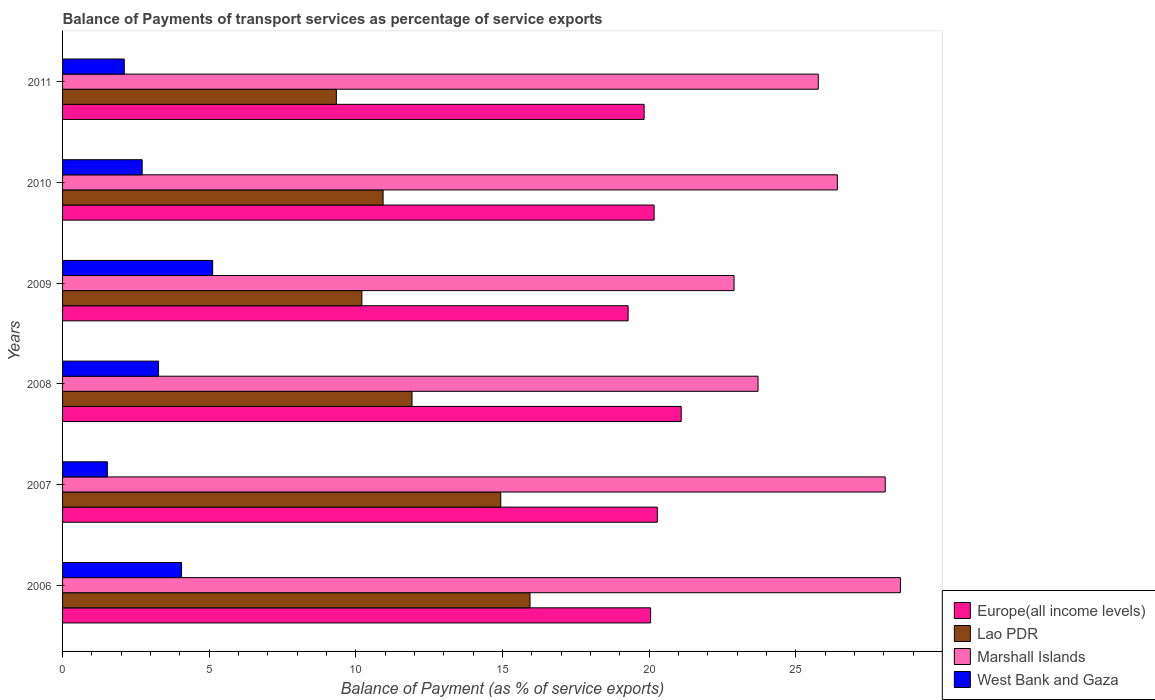How many bars are there on the 3rd tick from the top?
Provide a short and direct response. 4. What is the label of the 6th group of bars from the top?
Ensure brevity in your answer.  2006. What is the balance of payments of transport services in West Bank and Gaza in 2009?
Make the answer very short. 5.12. Across all years, what is the maximum balance of payments of transport services in West Bank and Gaza?
Offer a very short reply. 5.12. Across all years, what is the minimum balance of payments of transport services in West Bank and Gaza?
Offer a very short reply. 1.53. In which year was the balance of payments of transport services in Marshall Islands maximum?
Give a very brief answer. 2006. In which year was the balance of payments of transport services in West Bank and Gaza minimum?
Your answer should be compact. 2007. What is the total balance of payments of transport services in West Bank and Gaza in the graph?
Make the answer very short. 18.79. What is the difference between the balance of payments of transport services in Lao PDR in 2006 and that in 2011?
Give a very brief answer. 6.6. What is the difference between the balance of payments of transport services in Lao PDR in 2008 and the balance of payments of transport services in Europe(all income levels) in 2007?
Your answer should be very brief. -8.36. What is the average balance of payments of transport services in Lao PDR per year?
Offer a terse response. 12.21. In the year 2006, what is the difference between the balance of payments of transport services in Europe(all income levels) and balance of payments of transport services in Marshall Islands?
Provide a short and direct response. -8.52. What is the ratio of the balance of payments of transport services in Lao PDR in 2009 to that in 2010?
Keep it short and to the point. 0.93. Is the difference between the balance of payments of transport services in Europe(all income levels) in 2006 and 2010 greater than the difference between the balance of payments of transport services in Marshall Islands in 2006 and 2010?
Give a very brief answer. No. What is the difference between the highest and the second highest balance of payments of transport services in West Bank and Gaza?
Ensure brevity in your answer.  1.06. What is the difference between the highest and the lowest balance of payments of transport services in West Bank and Gaza?
Keep it short and to the point. 3.59. Is the sum of the balance of payments of transport services in Lao PDR in 2007 and 2011 greater than the maximum balance of payments of transport services in Europe(all income levels) across all years?
Your answer should be very brief. Yes. What does the 2nd bar from the top in 2008 represents?
Your answer should be very brief. Marshall Islands. What does the 1st bar from the bottom in 2008 represents?
Offer a terse response. Europe(all income levels). Is it the case that in every year, the sum of the balance of payments of transport services in West Bank and Gaza and balance of payments of transport services in Marshall Islands is greater than the balance of payments of transport services in Europe(all income levels)?
Your answer should be compact. Yes. What is the difference between two consecutive major ticks on the X-axis?
Give a very brief answer. 5. Does the graph contain any zero values?
Offer a terse response. No. Does the graph contain grids?
Offer a very short reply. No. Where does the legend appear in the graph?
Make the answer very short. Bottom right. How many legend labels are there?
Offer a terse response. 4. What is the title of the graph?
Your answer should be very brief. Balance of Payments of transport services as percentage of service exports. Does "Venezuela" appear as one of the legend labels in the graph?
Your answer should be very brief. No. What is the label or title of the X-axis?
Offer a very short reply. Balance of Payment (as % of service exports). What is the label or title of the Y-axis?
Ensure brevity in your answer.  Years. What is the Balance of Payment (as % of service exports) in Europe(all income levels) in 2006?
Offer a terse response. 20.05. What is the Balance of Payment (as % of service exports) of Lao PDR in 2006?
Offer a very short reply. 15.94. What is the Balance of Payment (as % of service exports) of Marshall Islands in 2006?
Offer a terse response. 28.56. What is the Balance of Payment (as % of service exports) of West Bank and Gaza in 2006?
Your answer should be very brief. 4.06. What is the Balance of Payment (as % of service exports) in Europe(all income levels) in 2007?
Offer a terse response. 20.28. What is the Balance of Payment (as % of service exports) of Lao PDR in 2007?
Your answer should be very brief. 14.94. What is the Balance of Payment (as % of service exports) of Marshall Islands in 2007?
Make the answer very short. 28.05. What is the Balance of Payment (as % of service exports) in West Bank and Gaza in 2007?
Your answer should be compact. 1.53. What is the Balance of Payment (as % of service exports) in Europe(all income levels) in 2008?
Your response must be concise. 21.09. What is the Balance of Payment (as % of service exports) of Lao PDR in 2008?
Your answer should be very brief. 11.91. What is the Balance of Payment (as % of service exports) in Marshall Islands in 2008?
Offer a very short reply. 23.71. What is the Balance of Payment (as % of service exports) of West Bank and Gaza in 2008?
Provide a succinct answer. 3.27. What is the Balance of Payment (as % of service exports) in Europe(all income levels) in 2009?
Ensure brevity in your answer.  19.28. What is the Balance of Payment (as % of service exports) in Lao PDR in 2009?
Give a very brief answer. 10.2. What is the Balance of Payment (as % of service exports) of Marshall Islands in 2009?
Ensure brevity in your answer.  22.89. What is the Balance of Payment (as % of service exports) in West Bank and Gaza in 2009?
Keep it short and to the point. 5.12. What is the Balance of Payment (as % of service exports) in Europe(all income levels) in 2010?
Offer a very short reply. 20.17. What is the Balance of Payment (as % of service exports) of Lao PDR in 2010?
Ensure brevity in your answer.  10.93. What is the Balance of Payment (as % of service exports) in Marshall Islands in 2010?
Your answer should be very brief. 26.41. What is the Balance of Payment (as % of service exports) in West Bank and Gaza in 2010?
Your response must be concise. 2.71. What is the Balance of Payment (as % of service exports) of Europe(all income levels) in 2011?
Your response must be concise. 19.83. What is the Balance of Payment (as % of service exports) in Lao PDR in 2011?
Make the answer very short. 9.33. What is the Balance of Payment (as % of service exports) in Marshall Islands in 2011?
Ensure brevity in your answer.  25.76. What is the Balance of Payment (as % of service exports) in West Bank and Gaza in 2011?
Offer a terse response. 2.1. Across all years, what is the maximum Balance of Payment (as % of service exports) in Europe(all income levels)?
Give a very brief answer. 21.09. Across all years, what is the maximum Balance of Payment (as % of service exports) in Lao PDR?
Keep it short and to the point. 15.94. Across all years, what is the maximum Balance of Payment (as % of service exports) in Marshall Islands?
Offer a very short reply. 28.56. Across all years, what is the maximum Balance of Payment (as % of service exports) of West Bank and Gaza?
Make the answer very short. 5.12. Across all years, what is the minimum Balance of Payment (as % of service exports) of Europe(all income levels)?
Your response must be concise. 19.28. Across all years, what is the minimum Balance of Payment (as % of service exports) of Lao PDR?
Your answer should be compact. 9.33. Across all years, what is the minimum Balance of Payment (as % of service exports) of Marshall Islands?
Provide a succinct answer. 22.89. Across all years, what is the minimum Balance of Payment (as % of service exports) in West Bank and Gaza?
Provide a succinct answer. 1.53. What is the total Balance of Payment (as % of service exports) of Europe(all income levels) in the graph?
Give a very brief answer. 120.69. What is the total Balance of Payment (as % of service exports) of Lao PDR in the graph?
Offer a very short reply. 73.25. What is the total Balance of Payment (as % of service exports) in Marshall Islands in the graph?
Provide a short and direct response. 155.39. What is the total Balance of Payment (as % of service exports) in West Bank and Gaza in the graph?
Make the answer very short. 18.79. What is the difference between the Balance of Payment (as % of service exports) in Europe(all income levels) in 2006 and that in 2007?
Provide a succinct answer. -0.23. What is the difference between the Balance of Payment (as % of service exports) in Marshall Islands in 2006 and that in 2007?
Provide a succinct answer. 0.52. What is the difference between the Balance of Payment (as % of service exports) of West Bank and Gaza in 2006 and that in 2007?
Your answer should be compact. 2.53. What is the difference between the Balance of Payment (as % of service exports) of Europe(all income levels) in 2006 and that in 2008?
Your response must be concise. -1.04. What is the difference between the Balance of Payment (as % of service exports) of Lao PDR in 2006 and that in 2008?
Ensure brevity in your answer.  4.02. What is the difference between the Balance of Payment (as % of service exports) of Marshall Islands in 2006 and that in 2008?
Make the answer very short. 4.85. What is the difference between the Balance of Payment (as % of service exports) of West Bank and Gaza in 2006 and that in 2008?
Give a very brief answer. 0.78. What is the difference between the Balance of Payment (as % of service exports) in Europe(all income levels) in 2006 and that in 2009?
Your response must be concise. 0.77. What is the difference between the Balance of Payment (as % of service exports) of Lao PDR in 2006 and that in 2009?
Make the answer very short. 5.73. What is the difference between the Balance of Payment (as % of service exports) in Marshall Islands in 2006 and that in 2009?
Keep it short and to the point. 5.67. What is the difference between the Balance of Payment (as % of service exports) of West Bank and Gaza in 2006 and that in 2009?
Keep it short and to the point. -1.06. What is the difference between the Balance of Payment (as % of service exports) of Europe(all income levels) in 2006 and that in 2010?
Keep it short and to the point. -0.12. What is the difference between the Balance of Payment (as % of service exports) in Lao PDR in 2006 and that in 2010?
Offer a very short reply. 5.01. What is the difference between the Balance of Payment (as % of service exports) of Marshall Islands in 2006 and that in 2010?
Your answer should be very brief. 2.15. What is the difference between the Balance of Payment (as % of service exports) of West Bank and Gaza in 2006 and that in 2010?
Offer a terse response. 1.34. What is the difference between the Balance of Payment (as % of service exports) of Europe(all income levels) in 2006 and that in 2011?
Ensure brevity in your answer.  0.22. What is the difference between the Balance of Payment (as % of service exports) in Lao PDR in 2006 and that in 2011?
Make the answer very short. 6.6. What is the difference between the Balance of Payment (as % of service exports) in Marshall Islands in 2006 and that in 2011?
Offer a terse response. 2.8. What is the difference between the Balance of Payment (as % of service exports) in West Bank and Gaza in 2006 and that in 2011?
Keep it short and to the point. 1.95. What is the difference between the Balance of Payment (as % of service exports) in Europe(all income levels) in 2007 and that in 2008?
Your answer should be compact. -0.82. What is the difference between the Balance of Payment (as % of service exports) in Lao PDR in 2007 and that in 2008?
Your answer should be very brief. 3.02. What is the difference between the Balance of Payment (as % of service exports) of Marshall Islands in 2007 and that in 2008?
Your answer should be very brief. 4.34. What is the difference between the Balance of Payment (as % of service exports) in West Bank and Gaza in 2007 and that in 2008?
Offer a terse response. -1.75. What is the difference between the Balance of Payment (as % of service exports) of Europe(all income levels) in 2007 and that in 2009?
Your answer should be very brief. 0.99. What is the difference between the Balance of Payment (as % of service exports) of Lao PDR in 2007 and that in 2009?
Your answer should be compact. 4.73. What is the difference between the Balance of Payment (as % of service exports) of Marshall Islands in 2007 and that in 2009?
Keep it short and to the point. 5.15. What is the difference between the Balance of Payment (as % of service exports) in West Bank and Gaza in 2007 and that in 2009?
Offer a very short reply. -3.59. What is the difference between the Balance of Payment (as % of service exports) of Europe(all income levels) in 2007 and that in 2010?
Provide a short and direct response. 0.11. What is the difference between the Balance of Payment (as % of service exports) in Lao PDR in 2007 and that in 2010?
Make the answer very short. 4.01. What is the difference between the Balance of Payment (as % of service exports) of Marshall Islands in 2007 and that in 2010?
Your response must be concise. 1.63. What is the difference between the Balance of Payment (as % of service exports) of West Bank and Gaza in 2007 and that in 2010?
Ensure brevity in your answer.  -1.19. What is the difference between the Balance of Payment (as % of service exports) of Europe(all income levels) in 2007 and that in 2011?
Ensure brevity in your answer.  0.45. What is the difference between the Balance of Payment (as % of service exports) of Lao PDR in 2007 and that in 2011?
Provide a short and direct response. 5.6. What is the difference between the Balance of Payment (as % of service exports) in Marshall Islands in 2007 and that in 2011?
Your response must be concise. 2.28. What is the difference between the Balance of Payment (as % of service exports) in West Bank and Gaza in 2007 and that in 2011?
Offer a terse response. -0.58. What is the difference between the Balance of Payment (as % of service exports) of Europe(all income levels) in 2008 and that in 2009?
Ensure brevity in your answer.  1.81. What is the difference between the Balance of Payment (as % of service exports) in Lao PDR in 2008 and that in 2009?
Provide a short and direct response. 1.71. What is the difference between the Balance of Payment (as % of service exports) of Marshall Islands in 2008 and that in 2009?
Ensure brevity in your answer.  0.82. What is the difference between the Balance of Payment (as % of service exports) in West Bank and Gaza in 2008 and that in 2009?
Keep it short and to the point. -1.85. What is the difference between the Balance of Payment (as % of service exports) in Europe(all income levels) in 2008 and that in 2010?
Keep it short and to the point. 0.92. What is the difference between the Balance of Payment (as % of service exports) in Lao PDR in 2008 and that in 2010?
Make the answer very short. 0.99. What is the difference between the Balance of Payment (as % of service exports) in Marshall Islands in 2008 and that in 2010?
Offer a terse response. -2.7. What is the difference between the Balance of Payment (as % of service exports) in West Bank and Gaza in 2008 and that in 2010?
Provide a short and direct response. 0.56. What is the difference between the Balance of Payment (as % of service exports) in Europe(all income levels) in 2008 and that in 2011?
Provide a succinct answer. 1.26. What is the difference between the Balance of Payment (as % of service exports) of Lao PDR in 2008 and that in 2011?
Keep it short and to the point. 2.58. What is the difference between the Balance of Payment (as % of service exports) of Marshall Islands in 2008 and that in 2011?
Offer a very short reply. -2.05. What is the difference between the Balance of Payment (as % of service exports) of West Bank and Gaza in 2008 and that in 2011?
Offer a very short reply. 1.17. What is the difference between the Balance of Payment (as % of service exports) in Europe(all income levels) in 2009 and that in 2010?
Your answer should be very brief. -0.89. What is the difference between the Balance of Payment (as % of service exports) of Lao PDR in 2009 and that in 2010?
Keep it short and to the point. -0.72. What is the difference between the Balance of Payment (as % of service exports) in Marshall Islands in 2009 and that in 2010?
Make the answer very short. -3.52. What is the difference between the Balance of Payment (as % of service exports) of West Bank and Gaza in 2009 and that in 2010?
Offer a terse response. 2.4. What is the difference between the Balance of Payment (as % of service exports) in Europe(all income levels) in 2009 and that in 2011?
Provide a short and direct response. -0.55. What is the difference between the Balance of Payment (as % of service exports) in Lao PDR in 2009 and that in 2011?
Your response must be concise. 0.87. What is the difference between the Balance of Payment (as % of service exports) of Marshall Islands in 2009 and that in 2011?
Provide a short and direct response. -2.87. What is the difference between the Balance of Payment (as % of service exports) in West Bank and Gaza in 2009 and that in 2011?
Offer a very short reply. 3.01. What is the difference between the Balance of Payment (as % of service exports) in Europe(all income levels) in 2010 and that in 2011?
Make the answer very short. 0.34. What is the difference between the Balance of Payment (as % of service exports) in Lao PDR in 2010 and that in 2011?
Your answer should be very brief. 1.59. What is the difference between the Balance of Payment (as % of service exports) of Marshall Islands in 2010 and that in 2011?
Offer a terse response. 0.65. What is the difference between the Balance of Payment (as % of service exports) of West Bank and Gaza in 2010 and that in 2011?
Provide a short and direct response. 0.61. What is the difference between the Balance of Payment (as % of service exports) of Europe(all income levels) in 2006 and the Balance of Payment (as % of service exports) of Lao PDR in 2007?
Provide a succinct answer. 5.11. What is the difference between the Balance of Payment (as % of service exports) of Europe(all income levels) in 2006 and the Balance of Payment (as % of service exports) of Marshall Islands in 2007?
Provide a succinct answer. -8. What is the difference between the Balance of Payment (as % of service exports) in Europe(all income levels) in 2006 and the Balance of Payment (as % of service exports) in West Bank and Gaza in 2007?
Your answer should be very brief. 18.52. What is the difference between the Balance of Payment (as % of service exports) of Lao PDR in 2006 and the Balance of Payment (as % of service exports) of Marshall Islands in 2007?
Offer a terse response. -12.11. What is the difference between the Balance of Payment (as % of service exports) of Lao PDR in 2006 and the Balance of Payment (as % of service exports) of West Bank and Gaza in 2007?
Offer a very short reply. 14.41. What is the difference between the Balance of Payment (as % of service exports) in Marshall Islands in 2006 and the Balance of Payment (as % of service exports) in West Bank and Gaza in 2007?
Provide a succinct answer. 27.04. What is the difference between the Balance of Payment (as % of service exports) in Europe(all income levels) in 2006 and the Balance of Payment (as % of service exports) in Lao PDR in 2008?
Keep it short and to the point. 8.14. What is the difference between the Balance of Payment (as % of service exports) in Europe(all income levels) in 2006 and the Balance of Payment (as % of service exports) in Marshall Islands in 2008?
Offer a terse response. -3.66. What is the difference between the Balance of Payment (as % of service exports) in Europe(all income levels) in 2006 and the Balance of Payment (as % of service exports) in West Bank and Gaza in 2008?
Ensure brevity in your answer.  16.78. What is the difference between the Balance of Payment (as % of service exports) in Lao PDR in 2006 and the Balance of Payment (as % of service exports) in Marshall Islands in 2008?
Your answer should be very brief. -7.77. What is the difference between the Balance of Payment (as % of service exports) in Lao PDR in 2006 and the Balance of Payment (as % of service exports) in West Bank and Gaza in 2008?
Give a very brief answer. 12.66. What is the difference between the Balance of Payment (as % of service exports) in Marshall Islands in 2006 and the Balance of Payment (as % of service exports) in West Bank and Gaza in 2008?
Keep it short and to the point. 25.29. What is the difference between the Balance of Payment (as % of service exports) in Europe(all income levels) in 2006 and the Balance of Payment (as % of service exports) in Lao PDR in 2009?
Your answer should be compact. 9.84. What is the difference between the Balance of Payment (as % of service exports) in Europe(all income levels) in 2006 and the Balance of Payment (as % of service exports) in Marshall Islands in 2009?
Ensure brevity in your answer.  -2.84. What is the difference between the Balance of Payment (as % of service exports) of Europe(all income levels) in 2006 and the Balance of Payment (as % of service exports) of West Bank and Gaza in 2009?
Offer a terse response. 14.93. What is the difference between the Balance of Payment (as % of service exports) of Lao PDR in 2006 and the Balance of Payment (as % of service exports) of Marshall Islands in 2009?
Keep it short and to the point. -6.96. What is the difference between the Balance of Payment (as % of service exports) in Lao PDR in 2006 and the Balance of Payment (as % of service exports) in West Bank and Gaza in 2009?
Ensure brevity in your answer.  10.82. What is the difference between the Balance of Payment (as % of service exports) in Marshall Islands in 2006 and the Balance of Payment (as % of service exports) in West Bank and Gaza in 2009?
Your response must be concise. 23.45. What is the difference between the Balance of Payment (as % of service exports) in Europe(all income levels) in 2006 and the Balance of Payment (as % of service exports) in Lao PDR in 2010?
Your answer should be very brief. 9.12. What is the difference between the Balance of Payment (as % of service exports) of Europe(all income levels) in 2006 and the Balance of Payment (as % of service exports) of Marshall Islands in 2010?
Make the answer very short. -6.37. What is the difference between the Balance of Payment (as % of service exports) in Europe(all income levels) in 2006 and the Balance of Payment (as % of service exports) in West Bank and Gaza in 2010?
Make the answer very short. 17.33. What is the difference between the Balance of Payment (as % of service exports) of Lao PDR in 2006 and the Balance of Payment (as % of service exports) of Marshall Islands in 2010?
Offer a terse response. -10.48. What is the difference between the Balance of Payment (as % of service exports) in Lao PDR in 2006 and the Balance of Payment (as % of service exports) in West Bank and Gaza in 2010?
Provide a succinct answer. 13.22. What is the difference between the Balance of Payment (as % of service exports) of Marshall Islands in 2006 and the Balance of Payment (as % of service exports) of West Bank and Gaza in 2010?
Your response must be concise. 25.85. What is the difference between the Balance of Payment (as % of service exports) in Europe(all income levels) in 2006 and the Balance of Payment (as % of service exports) in Lao PDR in 2011?
Make the answer very short. 10.71. What is the difference between the Balance of Payment (as % of service exports) of Europe(all income levels) in 2006 and the Balance of Payment (as % of service exports) of Marshall Islands in 2011?
Offer a terse response. -5.72. What is the difference between the Balance of Payment (as % of service exports) in Europe(all income levels) in 2006 and the Balance of Payment (as % of service exports) in West Bank and Gaza in 2011?
Ensure brevity in your answer.  17.94. What is the difference between the Balance of Payment (as % of service exports) in Lao PDR in 2006 and the Balance of Payment (as % of service exports) in Marshall Islands in 2011?
Your response must be concise. -9.83. What is the difference between the Balance of Payment (as % of service exports) of Lao PDR in 2006 and the Balance of Payment (as % of service exports) of West Bank and Gaza in 2011?
Provide a succinct answer. 13.83. What is the difference between the Balance of Payment (as % of service exports) of Marshall Islands in 2006 and the Balance of Payment (as % of service exports) of West Bank and Gaza in 2011?
Provide a succinct answer. 26.46. What is the difference between the Balance of Payment (as % of service exports) of Europe(all income levels) in 2007 and the Balance of Payment (as % of service exports) of Lao PDR in 2008?
Your answer should be compact. 8.36. What is the difference between the Balance of Payment (as % of service exports) in Europe(all income levels) in 2007 and the Balance of Payment (as % of service exports) in Marshall Islands in 2008?
Keep it short and to the point. -3.43. What is the difference between the Balance of Payment (as % of service exports) in Europe(all income levels) in 2007 and the Balance of Payment (as % of service exports) in West Bank and Gaza in 2008?
Make the answer very short. 17. What is the difference between the Balance of Payment (as % of service exports) in Lao PDR in 2007 and the Balance of Payment (as % of service exports) in Marshall Islands in 2008?
Offer a very short reply. -8.77. What is the difference between the Balance of Payment (as % of service exports) in Lao PDR in 2007 and the Balance of Payment (as % of service exports) in West Bank and Gaza in 2008?
Make the answer very short. 11.67. What is the difference between the Balance of Payment (as % of service exports) in Marshall Islands in 2007 and the Balance of Payment (as % of service exports) in West Bank and Gaza in 2008?
Provide a succinct answer. 24.77. What is the difference between the Balance of Payment (as % of service exports) of Europe(all income levels) in 2007 and the Balance of Payment (as % of service exports) of Lao PDR in 2009?
Your response must be concise. 10.07. What is the difference between the Balance of Payment (as % of service exports) in Europe(all income levels) in 2007 and the Balance of Payment (as % of service exports) in Marshall Islands in 2009?
Your answer should be very brief. -2.62. What is the difference between the Balance of Payment (as % of service exports) of Europe(all income levels) in 2007 and the Balance of Payment (as % of service exports) of West Bank and Gaza in 2009?
Your answer should be compact. 15.16. What is the difference between the Balance of Payment (as % of service exports) in Lao PDR in 2007 and the Balance of Payment (as % of service exports) in Marshall Islands in 2009?
Your answer should be very brief. -7.95. What is the difference between the Balance of Payment (as % of service exports) in Lao PDR in 2007 and the Balance of Payment (as % of service exports) in West Bank and Gaza in 2009?
Provide a short and direct response. 9.82. What is the difference between the Balance of Payment (as % of service exports) of Marshall Islands in 2007 and the Balance of Payment (as % of service exports) of West Bank and Gaza in 2009?
Offer a terse response. 22.93. What is the difference between the Balance of Payment (as % of service exports) in Europe(all income levels) in 2007 and the Balance of Payment (as % of service exports) in Lao PDR in 2010?
Your answer should be very brief. 9.35. What is the difference between the Balance of Payment (as % of service exports) in Europe(all income levels) in 2007 and the Balance of Payment (as % of service exports) in Marshall Islands in 2010?
Your response must be concise. -6.14. What is the difference between the Balance of Payment (as % of service exports) in Europe(all income levels) in 2007 and the Balance of Payment (as % of service exports) in West Bank and Gaza in 2010?
Ensure brevity in your answer.  17.56. What is the difference between the Balance of Payment (as % of service exports) of Lao PDR in 2007 and the Balance of Payment (as % of service exports) of Marshall Islands in 2010?
Provide a short and direct response. -11.48. What is the difference between the Balance of Payment (as % of service exports) in Lao PDR in 2007 and the Balance of Payment (as % of service exports) in West Bank and Gaza in 2010?
Provide a succinct answer. 12.22. What is the difference between the Balance of Payment (as % of service exports) of Marshall Islands in 2007 and the Balance of Payment (as % of service exports) of West Bank and Gaza in 2010?
Your answer should be very brief. 25.33. What is the difference between the Balance of Payment (as % of service exports) in Europe(all income levels) in 2007 and the Balance of Payment (as % of service exports) in Lao PDR in 2011?
Offer a very short reply. 10.94. What is the difference between the Balance of Payment (as % of service exports) of Europe(all income levels) in 2007 and the Balance of Payment (as % of service exports) of Marshall Islands in 2011?
Your response must be concise. -5.49. What is the difference between the Balance of Payment (as % of service exports) of Europe(all income levels) in 2007 and the Balance of Payment (as % of service exports) of West Bank and Gaza in 2011?
Provide a short and direct response. 18.17. What is the difference between the Balance of Payment (as % of service exports) in Lao PDR in 2007 and the Balance of Payment (as % of service exports) in Marshall Islands in 2011?
Your response must be concise. -10.83. What is the difference between the Balance of Payment (as % of service exports) in Lao PDR in 2007 and the Balance of Payment (as % of service exports) in West Bank and Gaza in 2011?
Your response must be concise. 12.83. What is the difference between the Balance of Payment (as % of service exports) of Marshall Islands in 2007 and the Balance of Payment (as % of service exports) of West Bank and Gaza in 2011?
Make the answer very short. 25.94. What is the difference between the Balance of Payment (as % of service exports) of Europe(all income levels) in 2008 and the Balance of Payment (as % of service exports) of Lao PDR in 2009?
Offer a very short reply. 10.89. What is the difference between the Balance of Payment (as % of service exports) in Europe(all income levels) in 2008 and the Balance of Payment (as % of service exports) in Marshall Islands in 2009?
Ensure brevity in your answer.  -1.8. What is the difference between the Balance of Payment (as % of service exports) in Europe(all income levels) in 2008 and the Balance of Payment (as % of service exports) in West Bank and Gaza in 2009?
Offer a very short reply. 15.97. What is the difference between the Balance of Payment (as % of service exports) in Lao PDR in 2008 and the Balance of Payment (as % of service exports) in Marshall Islands in 2009?
Ensure brevity in your answer.  -10.98. What is the difference between the Balance of Payment (as % of service exports) in Lao PDR in 2008 and the Balance of Payment (as % of service exports) in West Bank and Gaza in 2009?
Keep it short and to the point. 6.8. What is the difference between the Balance of Payment (as % of service exports) in Marshall Islands in 2008 and the Balance of Payment (as % of service exports) in West Bank and Gaza in 2009?
Your answer should be compact. 18.59. What is the difference between the Balance of Payment (as % of service exports) in Europe(all income levels) in 2008 and the Balance of Payment (as % of service exports) in Lao PDR in 2010?
Keep it short and to the point. 10.16. What is the difference between the Balance of Payment (as % of service exports) of Europe(all income levels) in 2008 and the Balance of Payment (as % of service exports) of Marshall Islands in 2010?
Your answer should be compact. -5.32. What is the difference between the Balance of Payment (as % of service exports) of Europe(all income levels) in 2008 and the Balance of Payment (as % of service exports) of West Bank and Gaza in 2010?
Keep it short and to the point. 18.38. What is the difference between the Balance of Payment (as % of service exports) in Lao PDR in 2008 and the Balance of Payment (as % of service exports) in Marshall Islands in 2010?
Your answer should be compact. -14.5. What is the difference between the Balance of Payment (as % of service exports) of Lao PDR in 2008 and the Balance of Payment (as % of service exports) of West Bank and Gaza in 2010?
Your response must be concise. 9.2. What is the difference between the Balance of Payment (as % of service exports) in Marshall Islands in 2008 and the Balance of Payment (as % of service exports) in West Bank and Gaza in 2010?
Give a very brief answer. 21. What is the difference between the Balance of Payment (as % of service exports) of Europe(all income levels) in 2008 and the Balance of Payment (as % of service exports) of Lao PDR in 2011?
Offer a terse response. 11.76. What is the difference between the Balance of Payment (as % of service exports) of Europe(all income levels) in 2008 and the Balance of Payment (as % of service exports) of Marshall Islands in 2011?
Ensure brevity in your answer.  -4.67. What is the difference between the Balance of Payment (as % of service exports) of Europe(all income levels) in 2008 and the Balance of Payment (as % of service exports) of West Bank and Gaza in 2011?
Your answer should be compact. 18.99. What is the difference between the Balance of Payment (as % of service exports) in Lao PDR in 2008 and the Balance of Payment (as % of service exports) in Marshall Islands in 2011?
Provide a succinct answer. -13.85. What is the difference between the Balance of Payment (as % of service exports) of Lao PDR in 2008 and the Balance of Payment (as % of service exports) of West Bank and Gaza in 2011?
Provide a short and direct response. 9.81. What is the difference between the Balance of Payment (as % of service exports) in Marshall Islands in 2008 and the Balance of Payment (as % of service exports) in West Bank and Gaza in 2011?
Provide a short and direct response. 21.61. What is the difference between the Balance of Payment (as % of service exports) of Europe(all income levels) in 2009 and the Balance of Payment (as % of service exports) of Lao PDR in 2010?
Your answer should be compact. 8.35. What is the difference between the Balance of Payment (as % of service exports) of Europe(all income levels) in 2009 and the Balance of Payment (as % of service exports) of Marshall Islands in 2010?
Provide a succinct answer. -7.13. What is the difference between the Balance of Payment (as % of service exports) in Europe(all income levels) in 2009 and the Balance of Payment (as % of service exports) in West Bank and Gaza in 2010?
Offer a terse response. 16.57. What is the difference between the Balance of Payment (as % of service exports) of Lao PDR in 2009 and the Balance of Payment (as % of service exports) of Marshall Islands in 2010?
Provide a short and direct response. -16.21. What is the difference between the Balance of Payment (as % of service exports) in Lao PDR in 2009 and the Balance of Payment (as % of service exports) in West Bank and Gaza in 2010?
Your response must be concise. 7.49. What is the difference between the Balance of Payment (as % of service exports) of Marshall Islands in 2009 and the Balance of Payment (as % of service exports) of West Bank and Gaza in 2010?
Your answer should be very brief. 20.18. What is the difference between the Balance of Payment (as % of service exports) in Europe(all income levels) in 2009 and the Balance of Payment (as % of service exports) in Lao PDR in 2011?
Ensure brevity in your answer.  9.95. What is the difference between the Balance of Payment (as % of service exports) of Europe(all income levels) in 2009 and the Balance of Payment (as % of service exports) of Marshall Islands in 2011?
Ensure brevity in your answer.  -6.48. What is the difference between the Balance of Payment (as % of service exports) in Europe(all income levels) in 2009 and the Balance of Payment (as % of service exports) in West Bank and Gaza in 2011?
Ensure brevity in your answer.  17.18. What is the difference between the Balance of Payment (as % of service exports) of Lao PDR in 2009 and the Balance of Payment (as % of service exports) of Marshall Islands in 2011?
Make the answer very short. -15.56. What is the difference between the Balance of Payment (as % of service exports) of Lao PDR in 2009 and the Balance of Payment (as % of service exports) of West Bank and Gaza in 2011?
Offer a very short reply. 8.1. What is the difference between the Balance of Payment (as % of service exports) of Marshall Islands in 2009 and the Balance of Payment (as % of service exports) of West Bank and Gaza in 2011?
Make the answer very short. 20.79. What is the difference between the Balance of Payment (as % of service exports) of Europe(all income levels) in 2010 and the Balance of Payment (as % of service exports) of Lao PDR in 2011?
Provide a short and direct response. 10.83. What is the difference between the Balance of Payment (as % of service exports) in Europe(all income levels) in 2010 and the Balance of Payment (as % of service exports) in Marshall Islands in 2011?
Provide a short and direct response. -5.6. What is the difference between the Balance of Payment (as % of service exports) in Europe(all income levels) in 2010 and the Balance of Payment (as % of service exports) in West Bank and Gaza in 2011?
Ensure brevity in your answer.  18.06. What is the difference between the Balance of Payment (as % of service exports) in Lao PDR in 2010 and the Balance of Payment (as % of service exports) in Marshall Islands in 2011?
Provide a succinct answer. -14.84. What is the difference between the Balance of Payment (as % of service exports) of Lao PDR in 2010 and the Balance of Payment (as % of service exports) of West Bank and Gaza in 2011?
Ensure brevity in your answer.  8.82. What is the difference between the Balance of Payment (as % of service exports) in Marshall Islands in 2010 and the Balance of Payment (as % of service exports) in West Bank and Gaza in 2011?
Offer a terse response. 24.31. What is the average Balance of Payment (as % of service exports) in Europe(all income levels) per year?
Your answer should be very brief. 20.11. What is the average Balance of Payment (as % of service exports) in Lao PDR per year?
Provide a succinct answer. 12.21. What is the average Balance of Payment (as % of service exports) of Marshall Islands per year?
Provide a succinct answer. 25.9. What is the average Balance of Payment (as % of service exports) of West Bank and Gaza per year?
Provide a short and direct response. 3.13. In the year 2006, what is the difference between the Balance of Payment (as % of service exports) in Europe(all income levels) and Balance of Payment (as % of service exports) in Lao PDR?
Your answer should be very brief. 4.11. In the year 2006, what is the difference between the Balance of Payment (as % of service exports) of Europe(all income levels) and Balance of Payment (as % of service exports) of Marshall Islands?
Provide a short and direct response. -8.52. In the year 2006, what is the difference between the Balance of Payment (as % of service exports) in Europe(all income levels) and Balance of Payment (as % of service exports) in West Bank and Gaza?
Ensure brevity in your answer.  15.99. In the year 2006, what is the difference between the Balance of Payment (as % of service exports) of Lao PDR and Balance of Payment (as % of service exports) of Marshall Islands?
Provide a short and direct response. -12.63. In the year 2006, what is the difference between the Balance of Payment (as % of service exports) of Lao PDR and Balance of Payment (as % of service exports) of West Bank and Gaza?
Make the answer very short. 11.88. In the year 2006, what is the difference between the Balance of Payment (as % of service exports) of Marshall Islands and Balance of Payment (as % of service exports) of West Bank and Gaza?
Your answer should be very brief. 24.51. In the year 2007, what is the difference between the Balance of Payment (as % of service exports) of Europe(all income levels) and Balance of Payment (as % of service exports) of Lao PDR?
Ensure brevity in your answer.  5.34. In the year 2007, what is the difference between the Balance of Payment (as % of service exports) in Europe(all income levels) and Balance of Payment (as % of service exports) in Marshall Islands?
Your answer should be very brief. -7.77. In the year 2007, what is the difference between the Balance of Payment (as % of service exports) of Europe(all income levels) and Balance of Payment (as % of service exports) of West Bank and Gaza?
Your answer should be very brief. 18.75. In the year 2007, what is the difference between the Balance of Payment (as % of service exports) in Lao PDR and Balance of Payment (as % of service exports) in Marshall Islands?
Offer a very short reply. -13.11. In the year 2007, what is the difference between the Balance of Payment (as % of service exports) of Lao PDR and Balance of Payment (as % of service exports) of West Bank and Gaza?
Ensure brevity in your answer.  13.41. In the year 2007, what is the difference between the Balance of Payment (as % of service exports) of Marshall Islands and Balance of Payment (as % of service exports) of West Bank and Gaza?
Provide a short and direct response. 26.52. In the year 2008, what is the difference between the Balance of Payment (as % of service exports) of Europe(all income levels) and Balance of Payment (as % of service exports) of Lao PDR?
Make the answer very short. 9.18. In the year 2008, what is the difference between the Balance of Payment (as % of service exports) of Europe(all income levels) and Balance of Payment (as % of service exports) of Marshall Islands?
Your answer should be compact. -2.62. In the year 2008, what is the difference between the Balance of Payment (as % of service exports) of Europe(all income levels) and Balance of Payment (as % of service exports) of West Bank and Gaza?
Offer a very short reply. 17.82. In the year 2008, what is the difference between the Balance of Payment (as % of service exports) in Lao PDR and Balance of Payment (as % of service exports) in Marshall Islands?
Give a very brief answer. -11.8. In the year 2008, what is the difference between the Balance of Payment (as % of service exports) in Lao PDR and Balance of Payment (as % of service exports) in West Bank and Gaza?
Ensure brevity in your answer.  8.64. In the year 2008, what is the difference between the Balance of Payment (as % of service exports) in Marshall Islands and Balance of Payment (as % of service exports) in West Bank and Gaza?
Offer a very short reply. 20.44. In the year 2009, what is the difference between the Balance of Payment (as % of service exports) of Europe(all income levels) and Balance of Payment (as % of service exports) of Lao PDR?
Provide a succinct answer. 9.08. In the year 2009, what is the difference between the Balance of Payment (as % of service exports) of Europe(all income levels) and Balance of Payment (as % of service exports) of Marshall Islands?
Provide a short and direct response. -3.61. In the year 2009, what is the difference between the Balance of Payment (as % of service exports) in Europe(all income levels) and Balance of Payment (as % of service exports) in West Bank and Gaza?
Your answer should be compact. 14.16. In the year 2009, what is the difference between the Balance of Payment (as % of service exports) of Lao PDR and Balance of Payment (as % of service exports) of Marshall Islands?
Keep it short and to the point. -12.69. In the year 2009, what is the difference between the Balance of Payment (as % of service exports) of Lao PDR and Balance of Payment (as % of service exports) of West Bank and Gaza?
Keep it short and to the point. 5.09. In the year 2009, what is the difference between the Balance of Payment (as % of service exports) in Marshall Islands and Balance of Payment (as % of service exports) in West Bank and Gaza?
Offer a terse response. 17.77. In the year 2010, what is the difference between the Balance of Payment (as % of service exports) of Europe(all income levels) and Balance of Payment (as % of service exports) of Lao PDR?
Ensure brevity in your answer.  9.24. In the year 2010, what is the difference between the Balance of Payment (as % of service exports) of Europe(all income levels) and Balance of Payment (as % of service exports) of Marshall Islands?
Provide a succinct answer. -6.25. In the year 2010, what is the difference between the Balance of Payment (as % of service exports) of Europe(all income levels) and Balance of Payment (as % of service exports) of West Bank and Gaza?
Give a very brief answer. 17.45. In the year 2010, what is the difference between the Balance of Payment (as % of service exports) in Lao PDR and Balance of Payment (as % of service exports) in Marshall Islands?
Provide a succinct answer. -15.49. In the year 2010, what is the difference between the Balance of Payment (as % of service exports) of Lao PDR and Balance of Payment (as % of service exports) of West Bank and Gaza?
Your answer should be very brief. 8.21. In the year 2010, what is the difference between the Balance of Payment (as % of service exports) in Marshall Islands and Balance of Payment (as % of service exports) in West Bank and Gaza?
Your response must be concise. 23.7. In the year 2011, what is the difference between the Balance of Payment (as % of service exports) of Europe(all income levels) and Balance of Payment (as % of service exports) of Lao PDR?
Offer a terse response. 10.49. In the year 2011, what is the difference between the Balance of Payment (as % of service exports) of Europe(all income levels) and Balance of Payment (as % of service exports) of Marshall Islands?
Your answer should be very brief. -5.94. In the year 2011, what is the difference between the Balance of Payment (as % of service exports) in Europe(all income levels) and Balance of Payment (as % of service exports) in West Bank and Gaza?
Your answer should be very brief. 17.72. In the year 2011, what is the difference between the Balance of Payment (as % of service exports) in Lao PDR and Balance of Payment (as % of service exports) in Marshall Islands?
Provide a short and direct response. -16.43. In the year 2011, what is the difference between the Balance of Payment (as % of service exports) in Lao PDR and Balance of Payment (as % of service exports) in West Bank and Gaza?
Provide a short and direct response. 7.23. In the year 2011, what is the difference between the Balance of Payment (as % of service exports) in Marshall Islands and Balance of Payment (as % of service exports) in West Bank and Gaza?
Provide a succinct answer. 23.66. What is the ratio of the Balance of Payment (as % of service exports) of Europe(all income levels) in 2006 to that in 2007?
Your answer should be very brief. 0.99. What is the ratio of the Balance of Payment (as % of service exports) in Lao PDR in 2006 to that in 2007?
Keep it short and to the point. 1.07. What is the ratio of the Balance of Payment (as % of service exports) of Marshall Islands in 2006 to that in 2007?
Your answer should be compact. 1.02. What is the ratio of the Balance of Payment (as % of service exports) of West Bank and Gaza in 2006 to that in 2007?
Your answer should be compact. 2.66. What is the ratio of the Balance of Payment (as % of service exports) in Europe(all income levels) in 2006 to that in 2008?
Offer a terse response. 0.95. What is the ratio of the Balance of Payment (as % of service exports) of Lao PDR in 2006 to that in 2008?
Give a very brief answer. 1.34. What is the ratio of the Balance of Payment (as % of service exports) of Marshall Islands in 2006 to that in 2008?
Keep it short and to the point. 1.2. What is the ratio of the Balance of Payment (as % of service exports) in West Bank and Gaza in 2006 to that in 2008?
Your response must be concise. 1.24. What is the ratio of the Balance of Payment (as % of service exports) in Europe(all income levels) in 2006 to that in 2009?
Offer a terse response. 1.04. What is the ratio of the Balance of Payment (as % of service exports) in Lao PDR in 2006 to that in 2009?
Provide a succinct answer. 1.56. What is the ratio of the Balance of Payment (as % of service exports) in Marshall Islands in 2006 to that in 2009?
Keep it short and to the point. 1.25. What is the ratio of the Balance of Payment (as % of service exports) in West Bank and Gaza in 2006 to that in 2009?
Make the answer very short. 0.79. What is the ratio of the Balance of Payment (as % of service exports) in Europe(all income levels) in 2006 to that in 2010?
Offer a very short reply. 0.99. What is the ratio of the Balance of Payment (as % of service exports) of Lao PDR in 2006 to that in 2010?
Offer a terse response. 1.46. What is the ratio of the Balance of Payment (as % of service exports) in Marshall Islands in 2006 to that in 2010?
Provide a succinct answer. 1.08. What is the ratio of the Balance of Payment (as % of service exports) of West Bank and Gaza in 2006 to that in 2010?
Your answer should be very brief. 1.49. What is the ratio of the Balance of Payment (as % of service exports) in Europe(all income levels) in 2006 to that in 2011?
Your response must be concise. 1.01. What is the ratio of the Balance of Payment (as % of service exports) in Lao PDR in 2006 to that in 2011?
Your answer should be compact. 1.71. What is the ratio of the Balance of Payment (as % of service exports) in Marshall Islands in 2006 to that in 2011?
Your answer should be very brief. 1.11. What is the ratio of the Balance of Payment (as % of service exports) of West Bank and Gaza in 2006 to that in 2011?
Your answer should be compact. 1.93. What is the ratio of the Balance of Payment (as % of service exports) in Europe(all income levels) in 2007 to that in 2008?
Provide a succinct answer. 0.96. What is the ratio of the Balance of Payment (as % of service exports) of Lao PDR in 2007 to that in 2008?
Your answer should be very brief. 1.25. What is the ratio of the Balance of Payment (as % of service exports) in Marshall Islands in 2007 to that in 2008?
Your answer should be compact. 1.18. What is the ratio of the Balance of Payment (as % of service exports) of West Bank and Gaza in 2007 to that in 2008?
Ensure brevity in your answer.  0.47. What is the ratio of the Balance of Payment (as % of service exports) in Europe(all income levels) in 2007 to that in 2009?
Give a very brief answer. 1.05. What is the ratio of the Balance of Payment (as % of service exports) of Lao PDR in 2007 to that in 2009?
Offer a very short reply. 1.46. What is the ratio of the Balance of Payment (as % of service exports) in Marshall Islands in 2007 to that in 2009?
Your response must be concise. 1.23. What is the ratio of the Balance of Payment (as % of service exports) in West Bank and Gaza in 2007 to that in 2009?
Your answer should be very brief. 0.3. What is the ratio of the Balance of Payment (as % of service exports) in Europe(all income levels) in 2007 to that in 2010?
Offer a very short reply. 1.01. What is the ratio of the Balance of Payment (as % of service exports) in Lao PDR in 2007 to that in 2010?
Provide a succinct answer. 1.37. What is the ratio of the Balance of Payment (as % of service exports) in Marshall Islands in 2007 to that in 2010?
Your answer should be very brief. 1.06. What is the ratio of the Balance of Payment (as % of service exports) in West Bank and Gaza in 2007 to that in 2010?
Offer a very short reply. 0.56. What is the ratio of the Balance of Payment (as % of service exports) of Europe(all income levels) in 2007 to that in 2011?
Provide a short and direct response. 1.02. What is the ratio of the Balance of Payment (as % of service exports) of Lao PDR in 2007 to that in 2011?
Your answer should be very brief. 1.6. What is the ratio of the Balance of Payment (as % of service exports) in Marshall Islands in 2007 to that in 2011?
Offer a very short reply. 1.09. What is the ratio of the Balance of Payment (as % of service exports) in West Bank and Gaza in 2007 to that in 2011?
Provide a succinct answer. 0.73. What is the ratio of the Balance of Payment (as % of service exports) in Europe(all income levels) in 2008 to that in 2009?
Give a very brief answer. 1.09. What is the ratio of the Balance of Payment (as % of service exports) of Lao PDR in 2008 to that in 2009?
Your answer should be compact. 1.17. What is the ratio of the Balance of Payment (as % of service exports) of Marshall Islands in 2008 to that in 2009?
Offer a terse response. 1.04. What is the ratio of the Balance of Payment (as % of service exports) in West Bank and Gaza in 2008 to that in 2009?
Give a very brief answer. 0.64. What is the ratio of the Balance of Payment (as % of service exports) in Europe(all income levels) in 2008 to that in 2010?
Provide a succinct answer. 1.05. What is the ratio of the Balance of Payment (as % of service exports) of Lao PDR in 2008 to that in 2010?
Your answer should be very brief. 1.09. What is the ratio of the Balance of Payment (as % of service exports) of Marshall Islands in 2008 to that in 2010?
Ensure brevity in your answer.  0.9. What is the ratio of the Balance of Payment (as % of service exports) of West Bank and Gaza in 2008 to that in 2010?
Make the answer very short. 1.21. What is the ratio of the Balance of Payment (as % of service exports) of Europe(all income levels) in 2008 to that in 2011?
Make the answer very short. 1.06. What is the ratio of the Balance of Payment (as % of service exports) of Lao PDR in 2008 to that in 2011?
Give a very brief answer. 1.28. What is the ratio of the Balance of Payment (as % of service exports) of Marshall Islands in 2008 to that in 2011?
Provide a succinct answer. 0.92. What is the ratio of the Balance of Payment (as % of service exports) of West Bank and Gaza in 2008 to that in 2011?
Provide a succinct answer. 1.56. What is the ratio of the Balance of Payment (as % of service exports) of Europe(all income levels) in 2009 to that in 2010?
Give a very brief answer. 0.96. What is the ratio of the Balance of Payment (as % of service exports) in Lao PDR in 2009 to that in 2010?
Make the answer very short. 0.93. What is the ratio of the Balance of Payment (as % of service exports) in Marshall Islands in 2009 to that in 2010?
Provide a succinct answer. 0.87. What is the ratio of the Balance of Payment (as % of service exports) in West Bank and Gaza in 2009 to that in 2010?
Your answer should be very brief. 1.89. What is the ratio of the Balance of Payment (as % of service exports) of Europe(all income levels) in 2009 to that in 2011?
Your response must be concise. 0.97. What is the ratio of the Balance of Payment (as % of service exports) in Lao PDR in 2009 to that in 2011?
Keep it short and to the point. 1.09. What is the ratio of the Balance of Payment (as % of service exports) in Marshall Islands in 2009 to that in 2011?
Provide a succinct answer. 0.89. What is the ratio of the Balance of Payment (as % of service exports) in West Bank and Gaza in 2009 to that in 2011?
Your answer should be compact. 2.43. What is the ratio of the Balance of Payment (as % of service exports) in Europe(all income levels) in 2010 to that in 2011?
Your response must be concise. 1.02. What is the ratio of the Balance of Payment (as % of service exports) in Lao PDR in 2010 to that in 2011?
Your answer should be very brief. 1.17. What is the ratio of the Balance of Payment (as % of service exports) of Marshall Islands in 2010 to that in 2011?
Offer a very short reply. 1.03. What is the ratio of the Balance of Payment (as % of service exports) in West Bank and Gaza in 2010 to that in 2011?
Offer a very short reply. 1.29. What is the difference between the highest and the second highest Balance of Payment (as % of service exports) in Europe(all income levels)?
Provide a succinct answer. 0.82. What is the difference between the highest and the second highest Balance of Payment (as % of service exports) of Lao PDR?
Provide a short and direct response. 1. What is the difference between the highest and the second highest Balance of Payment (as % of service exports) of Marshall Islands?
Your response must be concise. 0.52. What is the difference between the highest and the second highest Balance of Payment (as % of service exports) in West Bank and Gaza?
Provide a short and direct response. 1.06. What is the difference between the highest and the lowest Balance of Payment (as % of service exports) of Europe(all income levels)?
Your answer should be very brief. 1.81. What is the difference between the highest and the lowest Balance of Payment (as % of service exports) of Lao PDR?
Make the answer very short. 6.6. What is the difference between the highest and the lowest Balance of Payment (as % of service exports) of Marshall Islands?
Your answer should be compact. 5.67. What is the difference between the highest and the lowest Balance of Payment (as % of service exports) in West Bank and Gaza?
Provide a short and direct response. 3.59. 